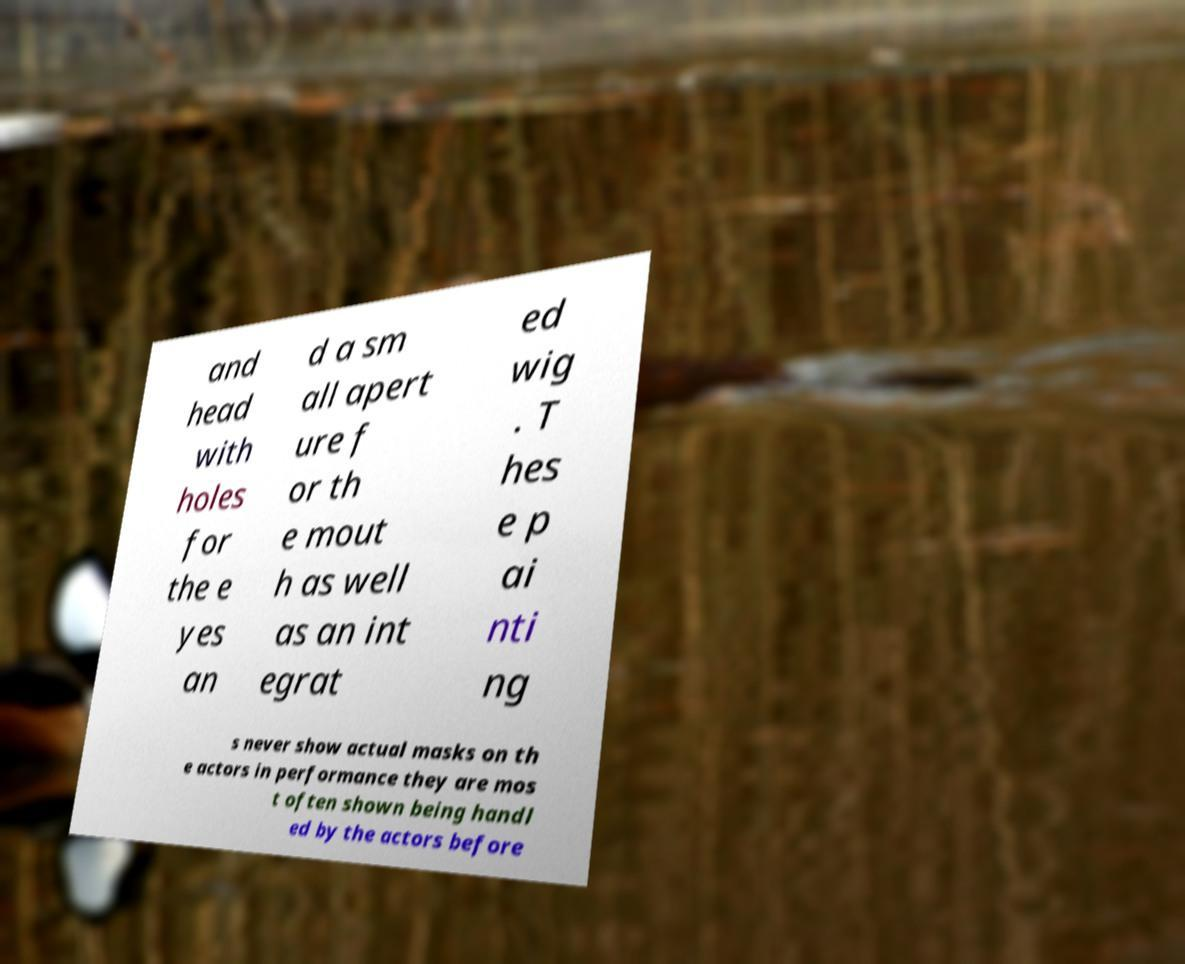Can you read and provide the text displayed in the image?This photo seems to have some interesting text. Can you extract and type it out for me? and head with holes for the e yes an d a sm all apert ure f or th e mout h as well as an int egrat ed wig . T hes e p ai nti ng s never show actual masks on th e actors in performance they are mos t often shown being handl ed by the actors before 